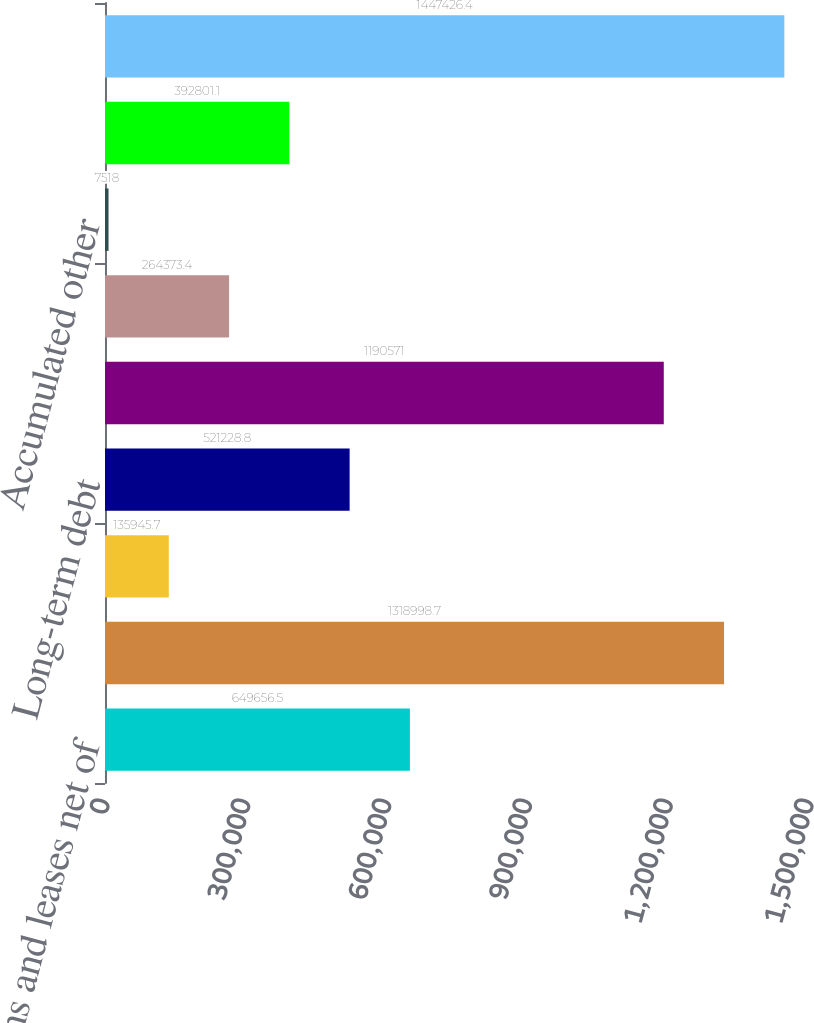Convert chart to OTSL. <chart><loc_0><loc_0><loc_500><loc_500><bar_chart><fcel>Loans and leases net of<fcel>Total assets<fcel>Accrued expenses and other<fcel>Long-term debt<fcel>Total liabilities<fcel>Retainedearnings<fcel>Accumulated other<fcel>Total shareholders' equity<fcel>Total liabilities and<nl><fcel>649656<fcel>1.319e+06<fcel>135946<fcel>521229<fcel>1.19057e+06<fcel>264373<fcel>7518<fcel>392801<fcel>1.44743e+06<nl></chart> 